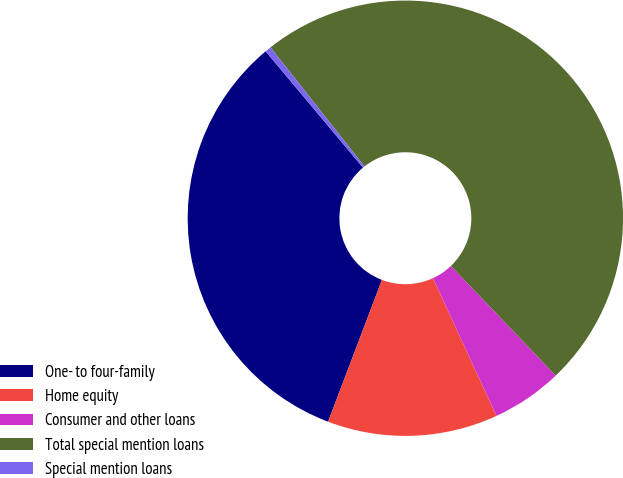<chart> <loc_0><loc_0><loc_500><loc_500><pie_chart><fcel>One- to four-family<fcel>Home equity<fcel>Consumer and other loans<fcel>Total special mention loans<fcel>Special mention loans<nl><fcel>33.13%<fcel>12.65%<fcel>5.26%<fcel>48.49%<fcel>0.46%<nl></chart> 